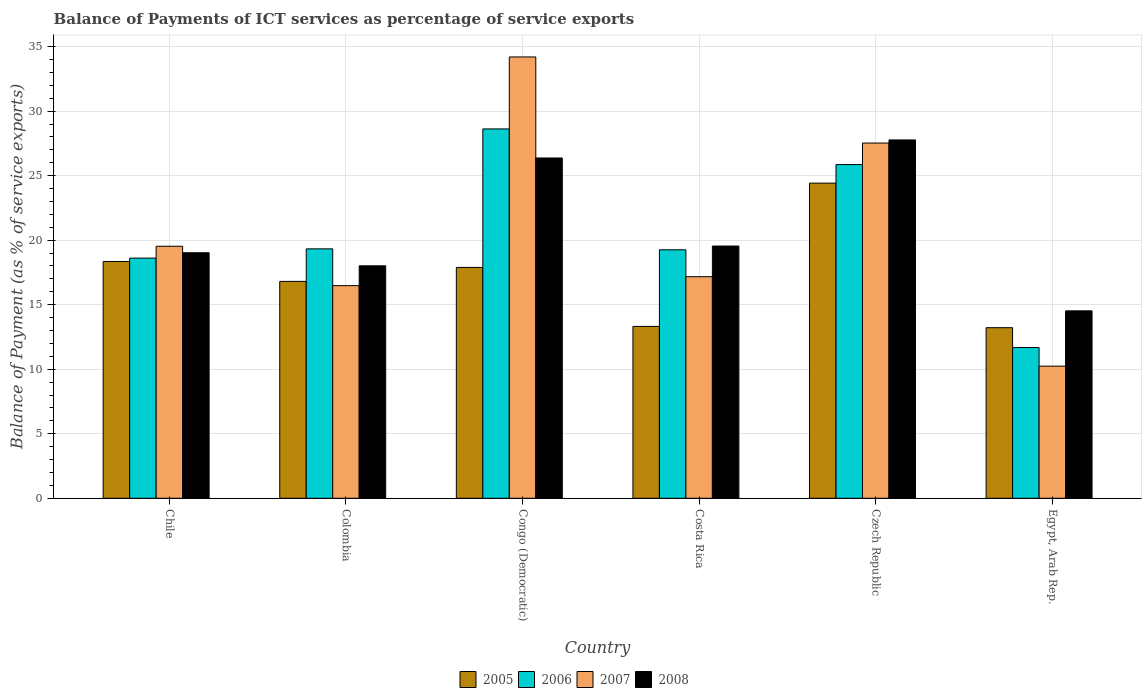How many different coloured bars are there?
Offer a terse response. 4. How many bars are there on the 2nd tick from the left?
Give a very brief answer. 4. What is the label of the 2nd group of bars from the left?
Offer a terse response. Colombia. In how many cases, is the number of bars for a given country not equal to the number of legend labels?
Your answer should be compact. 0. What is the balance of payments of ICT services in 2006 in Colombia?
Your answer should be very brief. 19.33. Across all countries, what is the maximum balance of payments of ICT services in 2006?
Provide a short and direct response. 28.62. Across all countries, what is the minimum balance of payments of ICT services in 2008?
Give a very brief answer. 14.52. In which country was the balance of payments of ICT services in 2007 maximum?
Provide a succinct answer. Congo (Democratic). In which country was the balance of payments of ICT services in 2005 minimum?
Provide a short and direct response. Egypt, Arab Rep. What is the total balance of payments of ICT services in 2006 in the graph?
Provide a short and direct response. 123.35. What is the difference between the balance of payments of ICT services in 2008 in Congo (Democratic) and that in Egypt, Arab Rep.?
Make the answer very short. 11.85. What is the difference between the balance of payments of ICT services in 2005 in Egypt, Arab Rep. and the balance of payments of ICT services in 2006 in Colombia?
Keep it short and to the point. -6.11. What is the average balance of payments of ICT services in 2007 per country?
Make the answer very short. 20.86. What is the difference between the balance of payments of ICT services of/in 2008 and balance of payments of ICT services of/in 2006 in Colombia?
Give a very brief answer. -1.32. In how many countries, is the balance of payments of ICT services in 2005 greater than 14 %?
Your answer should be very brief. 4. What is the ratio of the balance of payments of ICT services in 2006 in Czech Republic to that in Egypt, Arab Rep.?
Your response must be concise. 2.21. Is the difference between the balance of payments of ICT services in 2008 in Costa Rica and Egypt, Arab Rep. greater than the difference between the balance of payments of ICT services in 2006 in Costa Rica and Egypt, Arab Rep.?
Provide a short and direct response. No. What is the difference between the highest and the second highest balance of payments of ICT services in 2005?
Provide a short and direct response. 6.53. What is the difference between the highest and the lowest balance of payments of ICT services in 2006?
Ensure brevity in your answer.  16.94. What does the 1st bar from the left in Czech Republic represents?
Your answer should be compact. 2005. What does the 4th bar from the right in Egypt, Arab Rep. represents?
Your answer should be compact. 2005. How many bars are there?
Offer a terse response. 24. What is the difference between two consecutive major ticks on the Y-axis?
Your answer should be very brief. 5. Are the values on the major ticks of Y-axis written in scientific E-notation?
Provide a succinct answer. No. Does the graph contain grids?
Give a very brief answer. Yes. How many legend labels are there?
Your answer should be very brief. 4. What is the title of the graph?
Keep it short and to the point. Balance of Payments of ICT services as percentage of service exports. Does "1978" appear as one of the legend labels in the graph?
Give a very brief answer. No. What is the label or title of the X-axis?
Your response must be concise. Country. What is the label or title of the Y-axis?
Provide a short and direct response. Balance of Payment (as % of service exports). What is the Balance of Payment (as % of service exports) of 2005 in Chile?
Provide a short and direct response. 18.35. What is the Balance of Payment (as % of service exports) in 2006 in Chile?
Offer a very short reply. 18.61. What is the Balance of Payment (as % of service exports) of 2007 in Chile?
Make the answer very short. 19.53. What is the Balance of Payment (as % of service exports) in 2008 in Chile?
Keep it short and to the point. 19.03. What is the Balance of Payment (as % of service exports) of 2005 in Colombia?
Offer a very short reply. 16.81. What is the Balance of Payment (as % of service exports) in 2006 in Colombia?
Keep it short and to the point. 19.33. What is the Balance of Payment (as % of service exports) of 2007 in Colombia?
Your answer should be compact. 16.48. What is the Balance of Payment (as % of service exports) of 2008 in Colombia?
Keep it short and to the point. 18.01. What is the Balance of Payment (as % of service exports) of 2005 in Congo (Democratic)?
Give a very brief answer. 17.89. What is the Balance of Payment (as % of service exports) of 2006 in Congo (Democratic)?
Make the answer very short. 28.62. What is the Balance of Payment (as % of service exports) of 2007 in Congo (Democratic)?
Provide a succinct answer. 34.2. What is the Balance of Payment (as % of service exports) of 2008 in Congo (Democratic)?
Provide a succinct answer. 26.37. What is the Balance of Payment (as % of service exports) in 2005 in Costa Rica?
Your answer should be compact. 13.32. What is the Balance of Payment (as % of service exports) of 2006 in Costa Rica?
Your answer should be compact. 19.25. What is the Balance of Payment (as % of service exports) of 2007 in Costa Rica?
Give a very brief answer. 17.17. What is the Balance of Payment (as % of service exports) of 2008 in Costa Rica?
Provide a succinct answer. 19.55. What is the Balance of Payment (as % of service exports) in 2005 in Czech Republic?
Make the answer very short. 24.42. What is the Balance of Payment (as % of service exports) of 2006 in Czech Republic?
Your answer should be compact. 25.86. What is the Balance of Payment (as % of service exports) in 2007 in Czech Republic?
Give a very brief answer. 27.53. What is the Balance of Payment (as % of service exports) in 2008 in Czech Republic?
Offer a very short reply. 27.77. What is the Balance of Payment (as % of service exports) of 2005 in Egypt, Arab Rep.?
Ensure brevity in your answer.  13.22. What is the Balance of Payment (as % of service exports) in 2006 in Egypt, Arab Rep.?
Ensure brevity in your answer.  11.68. What is the Balance of Payment (as % of service exports) in 2007 in Egypt, Arab Rep.?
Offer a very short reply. 10.24. What is the Balance of Payment (as % of service exports) in 2008 in Egypt, Arab Rep.?
Offer a terse response. 14.52. Across all countries, what is the maximum Balance of Payment (as % of service exports) of 2005?
Ensure brevity in your answer.  24.42. Across all countries, what is the maximum Balance of Payment (as % of service exports) in 2006?
Give a very brief answer. 28.62. Across all countries, what is the maximum Balance of Payment (as % of service exports) in 2007?
Keep it short and to the point. 34.2. Across all countries, what is the maximum Balance of Payment (as % of service exports) in 2008?
Give a very brief answer. 27.77. Across all countries, what is the minimum Balance of Payment (as % of service exports) in 2005?
Your answer should be compact. 13.22. Across all countries, what is the minimum Balance of Payment (as % of service exports) in 2006?
Give a very brief answer. 11.68. Across all countries, what is the minimum Balance of Payment (as % of service exports) of 2007?
Your answer should be very brief. 10.24. Across all countries, what is the minimum Balance of Payment (as % of service exports) in 2008?
Give a very brief answer. 14.52. What is the total Balance of Payment (as % of service exports) of 2005 in the graph?
Give a very brief answer. 104.01. What is the total Balance of Payment (as % of service exports) of 2006 in the graph?
Offer a very short reply. 123.35. What is the total Balance of Payment (as % of service exports) of 2007 in the graph?
Your answer should be compact. 125.14. What is the total Balance of Payment (as % of service exports) of 2008 in the graph?
Provide a short and direct response. 125.25. What is the difference between the Balance of Payment (as % of service exports) in 2005 in Chile and that in Colombia?
Give a very brief answer. 1.54. What is the difference between the Balance of Payment (as % of service exports) of 2006 in Chile and that in Colombia?
Keep it short and to the point. -0.72. What is the difference between the Balance of Payment (as % of service exports) of 2007 in Chile and that in Colombia?
Ensure brevity in your answer.  3.05. What is the difference between the Balance of Payment (as % of service exports) of 2008 in Chile and that in Colombia?
Provide a succinct answer. 1.01. What is the difference between the Balance of Payment (as % of service exports) of 2005 in Chile and that in Congo (Democratic)?
Your answer should be compact. 0.46. What is the difference between the Balance of Payment (as % of service exports) in 2006 in Chile and that in Congo (Democratic)?
Provide a succinct answer. -10.01. What is the difference between the Balance of Payment (as % of service exports) in 2007 in Chile and that in Congo (Democratic)?
Make the answer very short. -14.67. What is the difference between the Balance of Payment (as % of service exports) of 2008 in Chile and that in Congo (Democratic)?
Your response must be concise. -7.34. What is the difference between the Balance of Payment (as % of service exports) of 2005 in Chile and that in Costa Rica?
Give a very brief answer. 5.03. What is the difference between the Balance of Payment (as % of service exports) of 2006 in Chile and that in Costa Rica?
Give a very brief answer. -0.64. What is the difference between the Balance of Payment (as % of service exports) in 2007 in Chile and that in Costa Rica?
Give a very brief answer. 2.36. What is the difference between the Balance of Payment (as % of service exports) in 2008 in Chile and that in Costa Rica?
Your response must be concise. -0.52. What is the difference between the Balance of Payment (as % of service exports) of 2005 in Chile and that in Czech Republic?
Your answer should be compact. -6.07. What is the difference between the Balance of Payment (as % of service exports) in 2006 in Chile and that in Czech Republic?
Keep it short and to the point. -7.25. What is the difference between the Balance of Payment (as % of service exports) of 2007 in Chile and that in Czech Republic?
Your response must be concise. -8. What is the difference between the Balance of Payment (as % of service exports) in 2008 in Chile and that in Czech Republic?
Give a very brief answer. -8.74. What is the difference between the Balance of Payment (as % of service exports) of 2005 in Chile and that in Egypt, Arab Rep.?
Make the answer very short. 5.13. What is the difference between the Balance of Payment (as % of service exports) in 2006 in Chile and that in Egypt, Arab Rep.?
Offer a terse response. 6.93. What is the difference between the Balance of Payment (as % of service exports) of 2007 in Chile and that in Egypt, Arab Rep.?
Offer a very short reply. 9.29. What is the difference between the Balance of Payment (as % of service exports) of 2008 in Chile and that in Egypt, Arab Rep.?
Offer a terse response. 4.5. What is the difference between the Balance of Payment (as % of service exports) in 2005 in Colombia and that in Congo (Democratic)?
Your answer should be compact. -1.08. What is the difference between the Balance of Payment (as % of service exports) of 2006 in Colombia and that in Congo (Democratic)?
Your answer should be very brief. -9.29. What is the difference between the Balance of Payment (as % of service exports) of 2007 in Colombia and that in Congo (Democratic)?
Offer a terse response. -17.72. What is the difference between the Balance of Payment (as % of service exports) in 2008 in Colombia and that in Congo (Democratic)?
Offer a terse response. -8.36. What is the difference between the Balance of Payment (as % of service exports) in 2005 in Colombia and that in Costa Rica?
Offer a terse response. 3.49. What is the difference between the Balance of Payment (as % of service exports) in 2006 in Colombia and that in Costa Rica?
Provide a short and direct response. 0.07. What is the difference between the Balance of Payment (as % of service exports) of 2007 in Colombia and that in Costa Rica?
Your response must be concise. -0.69. What is the difference between the Balance of Payment (as % of service exports) in 2008 in Colombia and that in Costa Rica?
Your response must be concise. -1.53. What is the difference between the Balance of Payment (as % of service exports) of 2005 in Colombia and that in Czech Republic?
Your response must be concise. -7.61. What is the difference between the Balance of Payment (as % of service exports) of 2006 in Colombia and that in Czech Republic?
Offer a terse response. -6.53. What is the difference between the Balance of Payment (as % of service exports) of 2007 in Colombia and that in Czech Republic?
Provide a succinct answer. -11.05. What is the difference between the Balance of Payment (as % of service exports) in 2008 in Colombia and that in Czech Republic?
Offer a terse response. -9.76. What is the difference between the Balance of Payment (as % of service exports) in 2005 in Colombia and that in Egypt, Arab Rep.?
Provide a short and direct response. 3.59. What is the difference between the Balance of Payment (as % of service exports) of 2006 in Colombia and that in Egypt, Arab Rep.?
Offer a very short reply. 7.65. What is the difference between the Balance of Payment (as % of service exports) of 2007 in Colombia and that in Egypt, Arab Rep.?
Offer a very short reply. 6.24. What is the difference between the Balance of Payment (as % of service exports) of 2008 in Colombia and that in Egypt, Arab Rep.?
Make the answer very short. 3.49. What is the difference between the Balance of Payment (as % of service exports) of 2005 in Congo (Democratic) and that in Costa Rica?
Your answer should be very brief. 4.57. What is the difference between the Balance of Payment (as % of service exports) of 2006 in Congo (Democratic) and that in Costa Rica?
Your answer should be very brief. 9.37. What is the difference between the Balance of Payment (as % of service exports) in 2007 in Congo (Democratic) and that in Costa Rica?
Offer a terse response. 17.03. What is the difference between the Balance of Payment (as % of service exports) of 2008 in Congo (Democratic) and that in Costa Rica?
Keep it short and to the point. 6.82. What is the difference between the Balance of Payment (as % of service exports) in 2005 in Congo (Democratic) and that in Czech Republic?
Give a very brief answer. -6.53. What is the difference between the Balance of Payment (as % of service exports) of 2006 in Congo (Democratic) and that in Czech Republic?
Make the answer very short. 2.76. What is the difference between the Balance of Payment (as % of service exports) of 2007 in Congo (Democratic) and that in Czech Republic?
Give a very brief answer. 6.67. What is the difference between the Balance of Payment (as % of service exports) of 2008 in Congo (Democratic) and that in Czech Republic?
Provide a short and direct response. -1.4. What is the difference between the Balance of Payment (as % of service exports) of 2005 in Congo (Democratic) and that in Egypt, Arab Rep.?
Offer a terse response. 4.67. What is the difference between the Balance of Payment (as % of service exports) in 2006 in Congo (Democratic) and that in Egypt, Arab Rep.?
Offer a terse response. 16.94. What is the difference between the Balance of Payment (as % of service exports) of 2007 in Congo (Democratic) and that in Egypt, Arab Rep.?
Provide a short and direct response. 23.96. What is the difference between the Balance of Payment (as % of service exports) of 2008 in Congo (Democratic) and that in Egypt, Arab Rep.?
Keep it short and to the point. 11.85. What is the difference between the Balance of Payment (as % of service exports) in 2005 in Costa Rica and that in Czech Republic?
Your answer should be compact. -11.1. What is the difference between the Balance of Payment (as % of service exports) of 2006 in Costa Rica and that in Czech Republic?
Give a very brief answer. -6.6. What is the difference between the Balance of Payment (as % of service exports) of 2007 in Costa Rica and that in Czech Republic?
Offer a very short reply. -10.36. What is the difference between the Balance of Payment (as % of service exports) of 2008 in Costa Rica and that in Czech Republic?
Your answer should be very brief. -8.22. What is the difference between the Balance of Payment (as % of service exports) in 2005 in Costa Rica and that in Egypt, Arab Rep.?
Your answer should be very brief. 0.1. What is the difference between the Balance of Payment (as % of service exports) in 2006 in Costa Rica and that in Egypt, Arab Rep.?
Offer a terse response. 7.57. What is the difference between the Balance of Payment (as % of service exports) in 2007 in Costa Rica and that in Egypt, Arab Rep.?
Ensure brevity in your answer.  6.93. What is the difference between the Balance of Payment (as % of service exports) of 2008 in Costa Rica and that in Egypt, Arab Rep.?
Offer a very short reply. 5.02. What is the difference between the Balance of Payment (as % of service exports) in 2005 in Czech Republic and that in Egypt, Arab Rep.?
Your response must be concise. 11.2. What is the difference between the Balance of Payment (as % of service exports) in 2006 in Czech Republic and that in Egypt, Arab Rep.?
Your answer should be compact. 14.18. What is the difference between the Balance of Payment (as % of service exports) of 2007 in Czech Republic and that in Egypt, Arab Rep.?
Give a very brief answer. 17.29. What is the difference between the Balance of Payment (as % of service exports) in 2008 in Czech Republic and that in Egypt, Arab Rep.?
Ensure brevity in your answer.  13.24. What is the difference between the Balance of Payment (as % of service exports) in 2005 in Chile and the Balance of Payment (as % of service exports) in 2006 in Colombia?
Ensure brevity in your answer.  -0.98. What is the difference between the Balance of Payment (as % of service exports) in 2005 in Chile and the Balance of Payment (as % of service exports) in 2007 in Colombia?
Give a very brief answer. 1.87. What is the difference between the Balance of Payment (as % of service exports) of 2005 in Chile and the Balance of Payment (as % of service exports) of 2008 in Colombia?
Make the answer very short. 0.34. What is the difference between the Balance of Payment (as % of service exports) in 2006 in Chile and the Balance of Payment (as % of service exports) in 2007 in Colombia?
Offer a very short reply. 2.13. What is the difference between the Balance of Payment (as % of service exports) of 2006 in Chile and the Balance of Payment (as % of service exports) of 2008 in Colombia?
Provide a succinct answer. 0.6. What is the difference between the Balance of Payment (as % of service exports) in 2007 in Chile and the Balance of Payment (as % of service exports) in 2008 in Colombia?
Your answer should be compact. 1.52. What is the difference between the Balance of Payment (as % of service exports) of 2005 in Chile and the Balance of Payment (as % of service exports) of 2006 in Congo (Democratic)?
Your answer should be compact. -10.27. What is the difference between the Balance of Payment (as % of service exports) of 2005 in Chile and the Balance of Payment (as % of service exports) of 2007 in Congo (Democratic)?
Offer a very short reply. -15.85. What is the difference between the Balance of Payment (as % of service exports) of 2005 in Chile and the Balance of Payment (as % of service exports) of 2008 in Congo (Democratic)?
Ensure brevity in your answer.  -8.02. What is the difference between the Balance of Payment (as % of service exports) of 2006 in Chile and the Balance of Payment (as % of service exports) of 2007 in Congo (Democratic)?
Ensure brevity in your answer.  -15.59. What is the difference between the Balance of Payment (as % of service exports) of 2006 in Chile and the Balance of Payment (as % of service exports) of 2008 in Congo (Democratic)?
Ensure brevity in your answer.  -7.76. What is the difference between the Balance of Payment (as % of service exports) in 2007 in Chile and the Balance of Payment (as % of service exports) in 2008 in Congo (Democratic)?
Give a very brief answer. -6.84. What is the difference between the Balance of Payment (as % of service exports) of 2005 in Chile and the Balance of Payment (as % of service exports) of 2006 in Costa Rica?
Provide a short and direct response. -0.9. What is the difference between the Balance of Payment (as % of service exports) of 2005 in Chile and the Balance of Payment (as % of service exports) of 2007 in Costa Rica?
Provide a succinct answer. 1.18. What is the difference between the Balance of Payment (as % of service exports) in 2005 in Chile and the Balance of Payment (as % of service exports) in 2008 in Costa Rica?
Your answer should be compact. -1.2. What is the difference between the Balance of Payment (as % of service exports) of 2006 in Chile and the Balance of Payment (as % of service exports) of 2007 in Costa Rica?
Keep it short and to the point. 1.44. What is the difference between the Balance of Payment (as % of service exports) of 2006 in Chile and the Balance of Payment (as % of service exports) of 2008 in Costa Rica?
Your response must be concise. -0.94. What is the difference between the Balance of Payment (as % of service exports) of 2007 in Chile and the Balance of Payment (as % of service exports) of 2008 in Costa Rica?
Ensure brevity in your answer.  -0.02. What is the difference between the Balance of Payment (as % of service exports) in 2005 in Chile and the Balance of Payment (as % of service exports) in 2006 in Czech Republic?
Give a very brief answer. -7.51. What is the difference between the Balance of Payment (as % of service exports) of 2005 in Chile and the Balance of Payment (as % of service exports) of 2007 in Czech Republic?
Your answer should be very brief. -9.18. What is the difference between the Balance of Payment (as % of service exports) of 2005 in Chile and the Balance of Payment (as % of service exports) of 2008 in Czech Republic?
Offer a terse response. -9.42. What is the difference between the Balance of Payment (as % of service exports) of 2006 in Chile and the Balance of Payment (as % of service exports) of 2007 in Czech Republic?
Your answer should be very brief. -8.92. What is the difference between the Balance of Payment (as % of service exports) in 2006 in Chile and the Balance of Payment (as % of service exports) in 2008 in Czech Republic?
Offer a very short reply. -9.16. What is the difference between the Balance of Payment (as % of service exports) of 2007 in Chile and the Balance of Payment (as % of service exports) of 2008 in Czech Republic?
Your response must be concise. -8.24. What is the difference between the Balance of Payment (as % of service exports) of 2005 in Chile and the Balance of Payment (as % of service exports) of 2006 in Egypt, Arab Rep.?
Keep it short and to the point. 6.67. What is the difference between the Balance of Payment (as % of service exports) of 2005 in Chile and the Balance of Payment (as % of service exports) of 2007 in Egypt, Arab Rep.?
Make the answer very short. 8.11. What is the difference between the Balance of Payment (as % of service exports) in 2005 in Chile and the Balance of Payment (as % of service exports) in 2008 in Egypt, Arab Rep.?
Give a very brief answer. 3.83. What is the difference between the Balance of Payment (as % of service exports) of 2006 in Chile and the Balance of Payment (as % of service exports) of 2007 in Egypt, Arab Rep.?
Provide a succinct answer. 8.37. What is the difference between the Balance of Payment (as % of service exports) in 2006 in Chile and the Balance of Payment (as % of service exports) in 2008 in Egypt, Arab Rep.?
Provide a short and direct response. 4.09. What is the difference between the Balance of Payment (as % of service exports) in 2007 in Chile and the Balance of Payment (as % of service exports) in 2008 in Egypt, Arab Rep.?
Your answer should be compact. 5.01. What is the difference between the Balance of Payment (as % of service exports) of 2005 in Colombia and the Balance of Payment (as % of service exports) of 2006 in Congo (Democratic)?
Keep it short and to the point. -11.81. What is the difference between the Balance of Payment (as % of service exports) in 2005 in Colombia and the Balance of Payment (as % of service exports) in 2007 in Congo (Democratic)?
Your answer should be compact. -17.39. What is the difference between the Balance of Payment (as % of service exports) in 2005 in Colombia and the Balance of Payment (as % of service exports) in 2008 in Congo (Democratic)?
Your response must be concise. -9.56. What is the difference between the Balance of Payment (as % of service exports) of 2006 in Colombia and the Balance of Payment (as % of service exports) of 2007 in Congo (Democratic)?
Your response must be concise. -14.87. What is the difference between the Balance of Payment (as % of service exports) in 2006 in Colombia and the Balance of Payment (as % of service exports) in 2008 in Congo (Democratic)?
Your answer should be compact. -7.04. What is the difference between the Balance of Payment (as % of service exports) of 2007 in Colombia and the Balance of Payment (as % of service exports) of 2008 in Congo (Democratic)?
Provide a succinct answer. -9.89. What is the difference between the Balance of Payment (as % of service exports) of 2005 in Colombia and the Balance of Payment (as % of service exports) of 2006 in Costa Rica?
Ensure brevity in your answer.  -2.45. What is the difference between the Balance of Payment (as % of service exports) in 2005 in Colombia and the Balance of Payment (as % of service exports) in 2007 in Costa Rica?
Your answer should be compact. -0.36. What is the difference between the Balance of Payment (as % of service exports) of 2005 in Colombia and the Balance of Payment (as % of service exports) of 2008 in Costa Rica?
Give a very brief answer. -2.74. What is the difference between the Balance of Payment (as % of service exports) in 2006 in Colombia and the Balance of Payment (as % of service exports) in 2007 in Costa Rica?
Your response must be concise. 2.16. What is the difference between the Balance of Payment (as % of service exports) in 2006 in Colombia and the Balance of Payment (as % of service exports) in 2008 in Costa Rica?
Provide a succinct answer. -0.22. What is the difference between the Balance of Payment (as % of service exports) in 2007 in Colombia and the Balance of Payment (as % of service exports) in 2008 in Costa Rica?
Provide a succinct answer. -3.07. What is the difference between the Balance of Payment (as % of service exports) in 2005 in Colombia and the Balance of Payment (as % of service exports) in 2006 in Czech Republic?
Offer a terse response. -9.05. What is the difference between the Balance of Payment (as % of service exports) of 2005 in Colombia and the Balance of Payment (as % of service exports) of 2007 in Czech Republic?
Your answer should be compact. -10.72. What is the difference between the Balance of Payment (as % of service exports) in 2005 in Colombia and the Balance of Payment (as % of service exports) in 2008 in Czech Republic?
Make the answer very short. -10.96. What is the difference between the Balance of Payment (as % of service exports) of 2006 in Colombia and the Balance of Payment (as % of service exports) of 2007 in Czech Republic?
Keep it short and to the point. -8.2. What is the difference between the Balance of Payment (as % of service exports) in 2006 in Colombia and the Balance of Payment (as % of service exports) in 2008 in Czech Republic?
Offer a terse response. -8.44. What is the difference between the Balance of Payment (as % of service exports) of 2007 in Colombia and the Balance of Payment (as % of service exports) of 2008 in Czech Republic?
Your answer should be compact. -11.29. What is the difference between the Balance of Payment (as % of service exports) of 2005 in Colombia and the Balance of Payment (as % of service exports) of 2006 in Egypt, Arab Rep.?
Your response must be concise. 5.13. What is the difference between the Balance of Payment (as % of service exports) in 2005 in Colombia and the Balance of Payment (as % of service exports) in 2007 in Egypt, Arab Rep.?
Keep it short and to the point. 6.57. What is the difference between the Balance of Payment (as % of service exports) in 2005 in Colombia and the Balance of Payment (as % of service exports) in 2008 in Egypt, Arab Rep.?
Ensure brevity in your answer.  2.28. What is the difference between the Balance of Payment (as % of service exports) in 2006 in Colombia and the Balance of Payment (as % of service exports) in 2007 in Egypt, Arab Rep.?
Your answer should be very brief. 9.09. What is the difference between the Balance of Payment (as % of service exports) of 2006 in Colombia and the Balance of Payment (as % of service exports) of 2008 in Egypt, Arab Rep.?
Provide a short and direct response. 4.8. What is the difference between the Balance of Payment (as % of service exports) of 2007 in Colombia and the Balance of Payment (as % of service exports) of 2008 in Egypt, Arab Rep.?
Provide a short and direct response. 1.95. What is the difference between the Balance of Payment (as % of service exports) of 2005 in Congo (Democratic) and the Balance of Payment (as % of service exports) of 2006 in Costa Rica?
Make the answer very short. -1.36. What is the difference between the Balance of Payment (as % of service exports) in 2005 in Congo (Democratic) and the Balance of Payment (as % of service exports) in 2007 in Costa Rica?
Offer a very short reply. 0.72. What is the difference between the Balance of Payment (as % of service exports) in 2005 in Congo (Democratic) and the Balance of Payment (as % of service exports) in 2008 in Costa Rica?
Offer a terse response. -1.66. What is the difference between the Balance of Payment (as % of service exports) of 2006 in Congo (Democratic) and the Balance of Payment (as % of service exports) of 2007 in Costa Rica?
Offer a terse response. 11.45. What is the difference between the Balance of Payment (as % of service exports) in 2006 in Congo (Democratic) and the Balance of Payment (as % of service exports) in 2008 in Costa Rica?
Provide a short and direct response. 9.07. What is the difference between the Balance of Payment (as % of service exports) in 2007 in Congo (Democratic) and the Balance of Payment (as % of service exports) in 2008 in Costa Rica?
Give a very brief answer. 14.65. What is the difference between the Balance of Payment (as % of service exports) of 2005 in Congo (Democratic) and the Balance of Payment (as % of service exports) of 2006 in Czech Republic?
Make the answer very short. -7.97. What is the difference between the Balance of Payment (as % of service exports) in 2005 in Congo (Democratic) and the Balance of Payment (as % of service exports) in 2007 in Czech Republic?
Provide a succinct answer. -9.64. What is the difference between the Balance of Payment (as % of service exports) in 2005 in Congo (Democratic) and the Balance of Payment (as % of service exports) in 2008 in Czech Republic?
Give a very brief answer. -9.88. What is the difference between the Balance of Payment (as % of service exports) in 2006 in Congo (Democratic) and the Balance of Payment (as % of service exports) in 2007 in Czech Republic?
Keep it short and to the point. 1.09. What is the difference between the Balance of Payment (as % of service exports) of 2006 in Congo (Democratic) and the Balance of Payment (as % of service exports) of 2008 in Czech Republic?
Give a very brief answer. 0.85. What is the difference between the Balance of Payment (as % of service exports) of 2007 in Congo (Democratic) and the Balance of Payment (as % of service exports) of 2008 in Czech Republic?
Offer a terse response. 6.43. What is the difference between the Balance of Payment (as % of service exports) of 2005 in Congo (Democratic) and the Balance of Payment (as % of service exports) of 2006 in Egypt, Arab Rep.?
Make the answer very short. 6.21. What is the difference between the Balance of Payment (as % of service exports) in 2005 in Congo (Democratic) and the Balance of Payment (as % of service exports) in 2007 in Egypt, Arab Rep.?
Provide a short and direct response. 7.65. What is the difference between the Balance of Payment (as % of service exports) of 2005 in Congo (Democratic) and the Balance of Payment (as % of service exports) of 2008 in Egypt, Arab Rep.?
Provide a succinct answer. 3.37. What is the difference between the Balance of Payment (as % of service exports) in 2006 in Congo (Democratic) and the Balance of Payment (as % of service exports) in 2007 in Egypt, Arab Rep.?
Offer a terse response. 18.38. What is the difference between the Balance of Payment (as % of service exports) of 2006 in Congo (Democratic) and the Balance of Payment (as % of service exports) of 2008 in Egypt, Arab Rep.?
Give a very brief answer. 14.1. What is the difference between the Balance of Payment (as % of service exports) in 2007 in Congo (Democratic) and the Balance of Payment (as % of service exports) in 2008 in Egypt, Arab Rep.?
Offer a terse response. 19.68. What is the difference between the Balance of Payment (as % of service exports) in 2005 in Costa Rica and the Balance of Payment (as % of service exports) in 2006 in Czech Republic?
Offer a very short reply. -12.54. What is the difference between the Balance of Payment (as % of service exports) of 2005 in Costa Rica and the Balance of Payment (as % of service exports) of 2007 in Czech Republic?
Offer a very short reply. -14.21. What is the difference between the Balance of Payment (as % of service exports) in 2005 in Costa Rica and the Balance of Payment (as % of service exports) in 2008 in Czech Republic?
Offer a terse response. -14.45. What is the difference between the Balance of Payment (as % of service exports) of 2006 in Costa Rica and the Balance of Payment (as % of service exports) of 2007 in Czech Republic?
Offer a terse response. -8.27. What is the difference between the Balance of Payment (as % of service exports) of 2006 in Costa Rica and the Balance of Payment (as % of service exports) of 2008 in Czech Republic?
Your response must be concise. -8.51. What is the difference between the Balance of Payment (as % of service exports) in 2007 in Costa Rica and the Balance of Payment (as % of service exports) in 2008 in Czech Republic?
Ensure brevity in your answer.  -10.6. What is the difference between the Balance of Payment (as % of service exports) in 2005 in Costa Rica and the Balance of Payment (as % of service exports) in 2006 in Egypt, Arab Rep.?
Offer a terse response. 1.64. What is the difference between the Balance of Payment (as % of service exports) of 2005 in Costa Rica and the Balance of Payment (as % of service exports) of 2007 in Egypt, Arab Rep.?
Your answer should be compact. 3.08. What is the difference between the Balance of Payment (as % of service exports) in 2005 in Costa Rica and the Balance of Payment (as % of service exports) in 2008 in Egypt, Arab Rep.?
Offer a very short reply. -1.21. What is the difference between the Balance of Payment (as % of service exports) of 2006 in Costa Rica and the Balance of Payment (as % of service exports) of 2007 in Egypt, Arab Rep.?
Your answer should be very brief. 9.02. What is the difference between the Balance of Payment (as % of service exports) of 2006 in Costa Rica and the Balance of Payment (as % of service exports) of 2008 in Egypt, Arab Rep.?
Offer a very short reply. 4.73. What is the difference between the Balance of Payment (as % of service exports) in 2007 in Costa Rica and the Balance of Payment (as % of service exports) in 2008 in Egypt, Arab Rep.?
Your answer should be compact. 2.65. What is the difference between the Balance of Payment (as % of service exports) in 2005 in Czech Republic and the Balance of Payment (as % of service exports) in 2006 in Egypt, Arab Rep.?
Make the answer very short. 12.74. What is the difference between the Balance of Payment (as % of service exports) in 2005 in Czech Republic and the Balance of Payment (as % of service exports) in 2007 in Egypt, Arab Rep.?
Provide a short and direct response. 14.18. What is the difference between the Balance of Payment (as % of service exports) in 2005 in Czech Republic and the Balance of Payment (as % of service exports) in 2008 in Egypt, Arab Rep.?
Your answer should be very brief. 9.9. What is the difference between the Balance of Payment (as % of service exports) of 2006 in Czech Republic and the Balance of Payment (as % of service exports) of 2007 in Egypt, Arab Rep.?
Offer a very short reply. 15.62. What is the difference between the Balance of Payment (as % of service exports) of 2006 in Czech Republic and the Balance of Payment (as % of service exports) of 2008 in Egypt, Arab Rep.?
Make the answer very short. 11.34. What is the difference between the Balance of Payment (as % of service exports) of 2007 in Czech Republic and the Balance of Payment (as % of service exports) of 2008 in Egypt, Arab Rep.?
Provide a short and direct response. 13. What is the average Balance of Payment (as % of service exports) of 2005 per country?
Provide a succinct answer. 17.33. What is the average Balance of Payment (as % of service exports) in 2006 per country?
Your answer should be compact. 20.56. What is the average Balance of Payment (as % of service exports) of 2007 per country?
Your answer should be very brief. 20.86. What is the average Balance of Payment (as % of service exports) of 2008 per country?
Your response must be concise. 20.88. What is the difference between the Balance of Payment (as % of service exports) in 2005 and Balance of Payment (as % of service exports) in 2006 in Chile?
Provide a succinct answer. -0.26. What is the difference between the Balance of Payment (as % of service exports) in 2005 and Balance of Payment (as % of service exports) in 2007 in Chile?
Provide a succinct answer. -1.18. What is the difference between the Balance of Payment (as % of service exports) of 2005 and Balance of Payment (as % of service exports) of 2008 in Chile?
Give a very brief answer. -0.68. What is the difference between the Balance of Payment (as % of service exports) in 2006 and Balance of Payment (as % of service exports) in 2007 in Chile?
Offer a terse response. -0.92. What is the difference between the Balance of Payment (as % of service exports) in 2006 and Balance of Payment (as % of service exports) in 2008 in Chile?
Provide a short and direct response. -0.42. What is the difference between the Balance of Payment (as % of service exports) in 2007 and Balance of Payment (as % of service exports) in 2008 in Chile?
Offer a very short reply. 0.5. What is the difference between the Balance of Payment (as % of service exports) in 2005 and Balance of Payment (as % of service exports) in 2006 in Colombia?
Offer a very short reply. -2.52. What is the difference between the Balance of Payment (as % of service exports) of 2005 and Balance of Payment (as % of service exports) of 2007 in Colombia?
Your answer should be very brief. 0.33. What is the difference between the Balance of Payment (as % of service exports) of 2005 and Balance of Payment (as % of service exports) of 2008 in Colombia?
Keep it short and to the point. -1.21. What is the difference between the Balance of Payment (as % of service exports) in 2006 and Balance of Payment (as % of service exports) in 2007 in Colombia?
Give a very brief answer. 2.85. What is the difference between the Balance of Payment (as % of service exports) in 2006 and Balance of Payment (as % of service exports) in 2008 in Colombia?
Your response must be concise. 1.32. What is the difference between the Balance of Payment (as % of service exports) of 2007 and Balance of Payment (as % of service exports) of 2008 in Colombia?
Offer a terse response. -1.54. What is the difference between the Balance of Payment (as % of service exports) of 2005 and Balance of Payment (as % of service exports) of 2006 in Congo (Democratic)?
Ensure brevity in your answer.  -10.73. What is the difference between the Balance of Payment (as % of service exports) in 2005 and Balance of Payment (as % of service exports) in 2007 in Congo (Democratic)?
Give a very brief answer. -16.31. What is the difference between the Balance of Payment (as % of service exports) in 2005 and Balance of Payment (as % of service exports) in 2008 in Congo (Democratic)?
Make the answer very short. -8.48. What is the difference between the Balance of Payment (as % of service exports) in 2006 and Balance of Payment (as % of service exports) in 2007 in Congo (Democratic)?
Your answer should be compact. -5.58. What is the difference between the Balance of Payment (as % of service exports) in 2006 and Balance of Payment (as % of service exports) in 2008 in Congo (Democratic)?
Give a very brief answer. 2.25. What is the difference between the Balance of Payment (as % of service exports) of 2007 and Balance of Payment (as % of service exports) of 2008 in Congo (Democratic)?
Provide a short and direct response. 7.83. What is the difference between the Balance of Payment (as % of service exports) in 2005 and Balance of Payment (as % of service exports) in 2006 in Costa Rica?
Your answer should be very brief. -5.94. What is the difference between the Balance of Payment (as % of service exports) in 2005 and Balance of Payment (as % of service exports) in 2007 in Costa Rica?
Make the answer very short. -3.85. What is the difference between the Balance of Payment (as % of service exports) in 2005 and Balance of Payment (as % of service exports) in 2008 in Costa Rica?
Give a very brief answer. -6.23. What is the difference between the Balance of Payment (as % of service exports) of 2006 and Balance of Payment (as % of service exports) of 2007 in Costa Rica?
Provide a succinct answer. 2.08. What is the difference between the Balance of Payment (as % of service exports) in 2006 and Balance of Payment (as % of service exports) in 2008 in Costa Rica?
Offer a very short reply. -0.29. What is the difference between the Balance of Payment (as % of service exports) of 2007 and Balance of Payment (as % of service exports) of 2008 in Costa Rica?
Offer a terse response. -2.38. What is the difference between the Balance of Payment (as % of service exports) of 2005 and Balance of Payment (as % of service exports) of 2006 in Czech Republic?
Offer a terse response. -1.44. What is the difference between the Balance of Payment (as % of service exports) in 2005 and Balance of Payment (as % of service exports) in 2007 in Czech Republic?
Offer a very short reply. -3.1. What is the difference between the Balance of Payment (as % of service exports) of 2005 and Balance of Payment (as % of service exports) of 2008 in Czech Republic?
Offer a terse response. -3.35. What is the difference between the Balance of Payment (as % of service exports) in 2006 and Balance of Payment (as % of service exports) in 2007 in Czech Republic?
Make the answer very short. -1.67. What is the difference between the Balance of Payment (as % of service exports) in 2006 and Balance of Payment (as % of service exports) in 2008 in Czech Republic?
Ensure brevity in your answer.  -1.91. What is the difference between the Balance of Payment (as % of service exports) of 2007 and Balance of Payment (as % of service exports) of 2008 in Czech Republic?
Make the answer very short. -0.24. What is the difference between the Balance of Payment (as % of service exports) of 2005 and Balance of Payment (as % of service exports) of 2006 in Egypt, Arab Rep.?
Provide a succinct answer. 1.54. What is the difference between the Balance of Payment (as % of service exports) in 2005 and Balance of Payment (as % of service exports) in 2007 in Egypt, Arab Rep.?
Offer a terse response. 2.98. What is the difference between the Balance of Payment (as % of service exports) in 2005 and Balance of Payment (as % of service exports) in 2008 in Egypt, Arab Rep.?
Give a very brief answer. -1.3. What is the difference between the Balance of Payment (as % of service exports) in 2006 and Balance of Payment (as % of service exports) in 2007 in Egypt, Arab Rep.?
Your answer should be very brief. 1.44. What is the difference between the Balance of Payment (as % of service exports) of 2006 and Balance of Payment (as % of service exports) of 2008 in Egypt, Arab Rep.?
Your answer should be compact. -2.84. What is the difference between the Balance of Payment (as % of service exports) of 2007 and Balance of Payment (as % of service exports) of 2008 in Egypt, Arab Rep.?
Keep it short and to the point. -4.29. What is the ratio of the Balance of Payment (as % of service exports) in 2005 in Chile to that in Colombia?
Your answer should be compact. 1.09. What is the ratio of the Balance of Payment (as % of service exports) of 2006 in Chile to that in Colombia?
Offer a very short reply. 0.96. What is the ratio of the Balance of Payment (as % of service exports) in 2007 in Chile to that in Colombia?
Keep it short and to the point. 1.19. What is the ratio of the Balance of Payment (as % of service exports) in 2008 in Chile to that in Colombia?
Offer a very short reply. 1.06. What is the ratio of the Balance of Payment (as % of service exports) of 2005 in Chile to that in Congo (Democratic)?
Keep it short and to the point. 1.03. What is the ratio of the Balance of Payment (as % of service exports) in 2006 in Chile to that in Congo (Democratic)?
Your response must be concise. 0.65. What is the ratio of the Balance of Payment (as % of service exports) of 2007 in Chile to that in Congo (Democratic)?
Provide a succinct answer. 0.57. What is the ratio of the Balance of Payment (as % of service exports) of 2008 in Chile to that in Congo (Democratic)?
Make the answer very short. 0.72. What is the ratio of the Balance of Payment (as % of service exports) in 2005 in Chile to that in Costa Rica?
Offer a very short reply. 1.38. What is the ratio of the Balance of Payment (as % of service exports) in 2006 in Chile to that in Costa Rica?
Keep it short and to the point. 0.97. What is the ratio of the Balance of Payment (as % of service exports) of 2007 in Chile to that in Costa Rica?
Offer a very short reply. 1.14. What is the ratio of the Balance of Payment (as % of service exports) in 2008 in Chile to that in Costa Rica?
Offer a very short reply. 0.97. What is the ratio of the Balance of Payment (as % of service exports) in 2005 in Chile to that in Czech Republic?
Keep it short and to the point. 0.75. What is the ratio of the Balance of Payment (as % of service exports) in 2006 in Chile to that in Czech Republic?
Offer a terse response. 0.72. What is the ratio of the Balance of Payment (as % of service exports) in 2007 in Chile to that in Czech Republic?
Ensure brevity in your answer.  0.71. What is the ratio of the Balance of Payment (as % of service exports) in 2008 in Chile to that in Czech Republic?
Ensure brevity in your answer.  0.69. What is the ratio of the Balance of Payment (as % of service exports) of 2005 in Chile to that in Egypt, Arab Rep.?
Give a very brief answer. 1.39. What is the ratio of the Balance of Payment (as % of service exports) of 2006 in Chile to that in Egypt, Arab Rep.?
Give a very brief answer. 1.59. What is the ratio of the Balance of Payment (as % of service exports) of 2007 in Chile to that in Egypt, Arab Rep.?
Ensure brevity in your answer.  1.91. What is the ratio of the Balance of Payment (as % of service exports) of 2008 in Chile to that in Egypt, Arab Rep.?
Give a very brief answer. 1.31. What is the ratio of the Balance of Payment (as % of service exports) in 2005 in Colombia to that in Congo (Democratic)?
Provide a succinct answer. 0.94. What is the ratio of the Balance of Payment (as % of service exports) in 2006 in Colombia to that in Congo (Democratic)?
Your answer should be compact. 0.68. What is the ratio of the Balance of Payment (as % of service exports) of 2007 in Colombia to that in Congo (Democratic)?
Your answer should be compact. 0.48. What is the ratio of the Balance of Payment (as % of service exports) in 2008 in Colombia to that in Congo (Democratic)?
Offer a terse response. 0.68. What is the ratio of the Balance of Payment (as % of service exports) in 2005 in Colombia to that in Costa Rica?
Offer a very short reply. 1.26. What is the ratio of the Balance of Payment (as % of service exports) in 2007 in Colombia to that in Costa Rica?
Provide a succinct answer. 0.96. What is the ratio of the Balance of Payment (as % of service exports) in 2008 in Colombia to that in Costa Rica?
Offer a very short reply. 0.92. What is the ratio of the Balance of Payment (as % of service exports) of 2005 in Colombia to that in Czech Republic?
Keep it short and to the point. 0.69. What is the ratio of the Balance of Payment (as % of service exports) of 2006 in Colombia to that in Czech Republic?
Provide a short and direct response. 0.75. What is the ratio of the Balance of Payment (as % of service exports) of 2007 in Colombia to that in Czech Republic?
Provide a short and direct response. 0.6. What is the ratio of the Balance of Payment (as % of service exports) of 2008 in Colombia to that in Czech Republic?
Offer a terse response. 0.65. What is the ratio of the Balance of Payment (as % of service exports) in 2005 in Colombia to that in Egypt, Arab Rep.?
Your answer should be compact. 1.27. What is the ratio of the Balance of Payment (as % of service exports) in 2006 in Colombia to that in Egypt, Arab Rep.?
Make the answer very short. 1.65. What is the ratio of the Balance of Payment (as % of service exports) in 2007 in Colombia to that in Egypt, Arab Rep.?
Your response must be concise. 1.61. What is the ratio of the Balance of Payment (as % of service exports) in 2008 in Colombia to that in Egypt, Arab Rep.?
Make the answer very short. 1.24. What is the ratio of the Balance of Payment (as % of service exports) of 2005 in Congo (Democratic) to that in Costa Rica?
Give a very brief answer. 1.34. What is the ratio of the Balance of Payment (as % of service exports) in 2006 in Congo (Democratic) to that in Costa Rica?
Your response must be concise. 1.49. What is the ratio of the Balance of Payment (as % of service exports) in 2007 in Congo (Democratic) to that in Costa Rica?
Give a very brief answer. 1.99. What is the ratio of the Balance of Payment (as % of service exports) of 2008 in Congo (Democratic) to that in Costa Rica?
Make the answer very short. 1.35. What is the ratio of the Balance of Payment (as % of service exports) of 2005 in Congo (Democratic) to that in Czech Republic?
Make the answer very short. 0.73. What is the ratio of the Balance of Payment (as % of service exports) of 2006 in Congo (Democratic) to that in Czech Republic?
Ensure brevity in your answer.  1.11. What is the ratio of the Balance of Payment (as % of service exports) of 2007 in Congo (Democratic) to that in Czech Republic?
Your answer should be very brief. 1.24. What is the ratio of the Balance of Payment (as % of service exports) of 2008 in Congo (Democratic) to that in Czech Republic?
Offer a very short reply. 0.95. What is the ratio of the Balance of Payment (as % of service exports) in 2005 in Congo (Democratic) to that in Egypt, Arab Rep.?
Offer a terse response. 1.35. What is the ratio of the Balance of Payment (as % of service exports) in 2006 in Congo (Democratic) to that in Egypt, Arab Rep.?
Your answer should be compact. 2.45. What is the ratio of the Balance of Payment (as % of service exports) in 2007 in Congo (Democratic) to that in Egypt, Arab Rep.?
Offer a very short reply. 3.34. What is the ratio of the Balance of Payment (as % of service exports) in 2008 in Congo (Democratic) to that in Egypt, Arab Rep.?
Provide a short and direct response. 1.82. What is the ratio of the Balance of Payment (as % of service exports) in 2005 in Costa Rica to that in Czech Republic?
Provide a succinct answer. 0.55. What is the ratio of the Balance of Payment (as % of service exports) in 2006 in Costa Rica to that in Czech Republic?
Ensure brevity in your answer.  0.74. What is the ratio of the Balance of Payment (as % of service exports) of 2007 in Costa Rica to that in Czech Republic?
Your response must be concise. 0.62. What is the ratio of the Balance of Payment (as % of service exports) in 2008 in Costa Rica to that in Czech Republic?
Make the answer very short. 0.7. What is the ratio of the Balance of Payment (as % of service exports) of 2005 in Costa Rica to that in Egypt, Arab Rep.?
Give a very brief answer. 1.01. What is the ratio of the Balance of Payment (as % of service exports) in 2006 in Costa Rica to that in Egypt, Arab Rep.?
Make the answer very short. 1.65. What is the ratio of the Balance of Payment (as % of service exports) in 2007 in Costa Rica to that in Egypt, Arab Rep.?
Make the answer very short. 1.68. What is the ratio of the Balance of Payment (as % of service exports) in 2008 in Costa Rica to that in Egypt, Arab Rep.?
Give a very brief answer. 1.35. What is the ratio of the Balance of Payment (as % of service exports) in 2005 in Czech Republic to that in Egypt, Arab Rep.?
Provide a succinct answer. 1.85. What is the ratio of the Balance of Payment (as % of service exports) in 2006 in Czech Republic to that in Egypt, Arab Rep.?
Provide a succinct answer. 2.21. What is the ratio of the Balance of Payment (as % of service exports) in 2007 in Czech Republic to that in Egypt, Arab Rep.?
Offer a terse response. 2.69. What is the ratio of the Balance of Payment (as % of service exports) in 2008 in Czech Republic to that in Egypt, Arab Rep.?
Ensure brevity in your answer.  1.91. What is the difference between the highest and the second highest Balance of Payment (as % of service exports) in 2005?
Your response must be concise. 6.07. What is the difference between the highest and the second highest Balance of Payment (as % of service exports) of 2006?
Offer a terse response. 2.76. What is the difference between the highest and the second highest Balance of Payment (as % of service exports) of 2007?
Give a very brief answer. 6.67. What is the difference between the highest and the second highest Balance of Payment (as % of service exports) of 2008?
Offer a terse response. 1.4. What is the difference between the highest and the lowest Balance of Payment (as % of service exports) in 2005?
Provide a short and direct response. 11.2. What is the difference between the highest and the lowest Balance of Payment (as % of service exports) of 2006?
Give a very brief answer. 16.94. What is the difference between the highest and the lowest Balance of Payment (as % of service exports) of 2007?
Give a very brief answer. 23.96. What is the difference between the highest and the lowest Balance of Payment (as % of service exports) of 2008?
Offer a terse response. 13.24. 